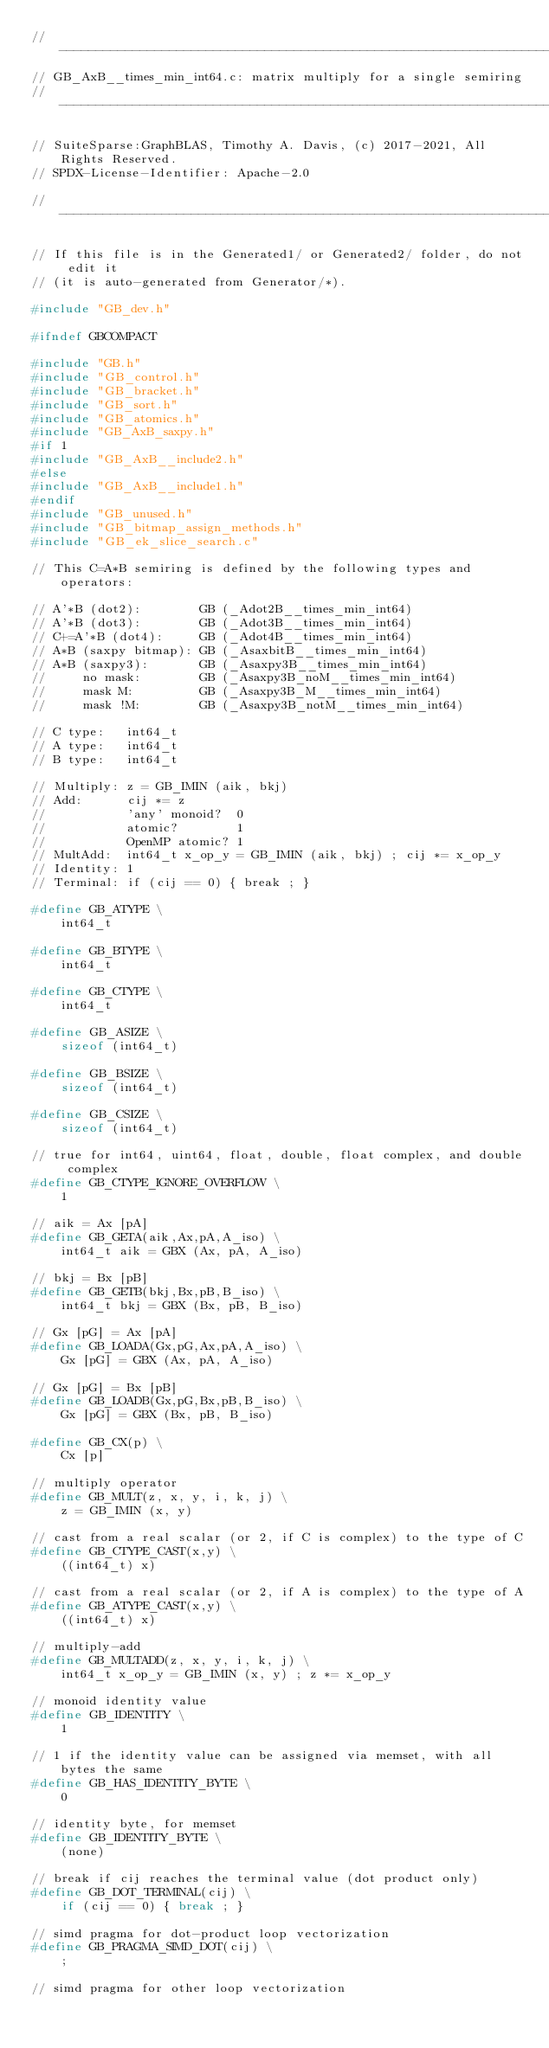Convert code to text. <code><loc_0><loc_0><loc_500><loc_500><_C_>//------------------------------------------------------------------------------
// GB_AxB__times_min_int64.c: matrix multiply for a single semiring
//------------------------------------------------------------------------------

// SuiteSparse:GraphBLAS, Timothy A. Davis, (c) 2017-2021, All Rights Reserved.
// SPDX-License-Identifier: Apache-2.0

//------------------------------------------------------------------------------

// If this file is in the Generated1/ or Generated2/ folder, do not edit it
// (it is auto-generated from Generator/*).

#include "GB_dev.h"

#ifndef GBCOMPACT

#include "GB.h"
#include "GB_control.h"
#include "GB_bracket.h"
#include "GB_sort.h"
#include "GB_atomics.h"
#include "GB_AxB_saxpy.h"
#if 1
#include "GB_AxB__include2.h"
#else
#include "GB_AxB__include1.h"
#endif
#include "GB_unused.h"
#include "GB_bitmap_assign_methods.h"
#include "GB_ek_slice_search.c"

// This C=A*B semiring is defined by the following types and operators:

// A'*B (dot2):        GB (_Adot2B__times_min_int64)
// A'*B (dot3):        GB (_Adot3B__times_min_int64)
// C+=A'*B (dot4):     GB (_Adot4B__times_min_int64)
// A*B (saxpy bitmap): GB (_AsaxbitB__times_min_int64)
// A*B (saxpy3):       GB (_Asaxpy3B__times_min_int64)
//     no mask:        GB (_Asaxpy3B_noM__times_min_int64)
//     mask M:         GB (_Asaxpy3B_M__times_min_int64)
//     mask !M:        GB (_Asaxpy3B_notM__times_min_int64)

// C type:   int64_t
// A type:   int64_t
// B type:   int64_t

// Multiply: z = GB_IMIN (aik, bkj)
// Add:      cij *= z
//           'any' monoid?  0
//           atomic?        1
//           OpenMP atomic? 1
// MultAdd:  int64_t x_op_y = GB_IMIN (aik, bkj) ; cij *= x_op_y
// Identity: 1
// Terminal: if (cij == 0) { break ; }

#define GB_ATYPE \
    int64_t

#define GB_BTYPE \
    int64_t

#define GB_CTYPE \
    int64_t

#define GB_ASIZE \
    sizeof (int64_t)

#define GB_BSIZE \
    sizeof (int64_t) 

#define GB_CSIZE \
    sizeof (int64_t)

// true for int64, uint64, float, double, float complex, and double complex 
#define GB_CTYPE_IGNORE_OVERFLOW \
    1

// aik = Ax [pA]
#define GB_GETA(aik,Ax,pA,A_iso) \
    int64_t aik = GBX (Ax, pA, A_iso)

// bkj = Bx [pB]
#define GB_GETB(bkj,Bx,pB,B_iso) \
    int64_t bkj = GBX (Bx, pB, B_iso)

// Gx [pG] = Ax [pA]
#define GB_LOADA(Gx,pG,Ax,pA,A_iso) \
    Gx [pG] = GBX (Ax, pA, A_iso)

// Gx [pG] = Bx [pB]
#define GB_LOADB(Gx,pG,Bx,pB,B_iso) \
    Gx [pG] = GBX (Bx, pB, B_iso)

#define GB_CX(p) \
    Cx [p]

// multiply operator
#define GB_MULT(z, x, y, i, k, j) \
    z = GB_IMIN (x, y)

// cast from a real scalar (or 2, if C is complex) to the type of C
#define GB_CTYPE_CAST(x,y) \
    ((int64_t) x)

// cast from a real scalar (or 2, if A is complex) to the type of A
#define GB_ATYPE_CAST(x,y) \
    ((int64_t) x)

// multiply-add
#define GB_MULTADD(z, x, y, i, k, j) \
    int64_t x_op_y = GB_IMIN (x, y) ; z *= x_op_y

// monoid identity value
#define GB_IDENTITY \
    1

// 1 if the identity value can be assigned via memset, with all bytes the same
#define GB_HAS_IDENTITY_BYTE \
    0

// identity byte, for memset
#define GB_IDENTITY_BYTE \
    (none)

// break if cij reaches the terminal value (dot product only)
#define GB_DOT_TERMINAL(cij) \
    if (cij == 0) { break ; }

// simd pragma for dot-product loop vectorization
#define GB_PRAGMA_SIMD_DOT(cij) \
    ;

// simd pragma for other loop vectorization</code> 